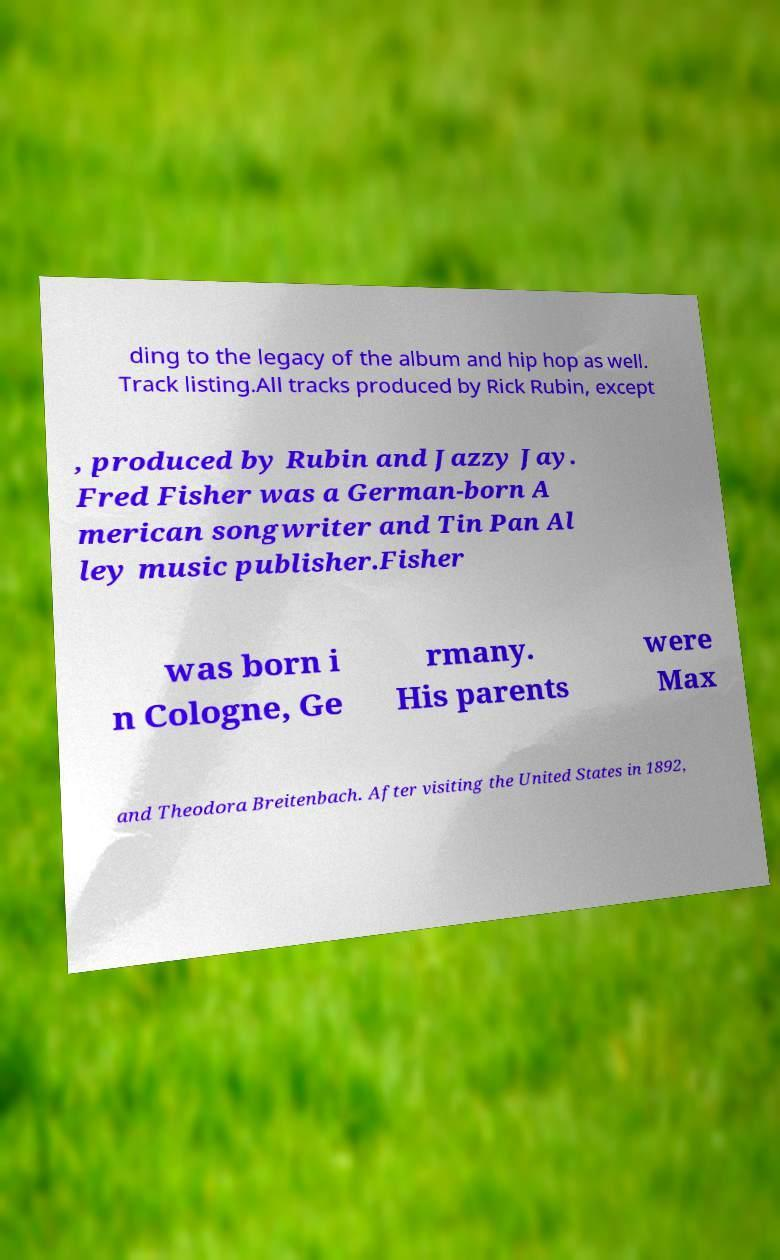For documentation purposes, I need the text within this image transcribed. Could you provide that? ding to the legacy of the album and hip hop as well. Track listing.All tracks produced by Rick Rubin, except , produced by Rubin and Jazzy Jay. Fred Fisher was a German-born A merican songwriter and Tin Pan Al ley music publisher.Fisher was born i n Cologne, Ge rmany. His parents were Max and Theodora Breitenbach. After visiting the United States in 1892, 